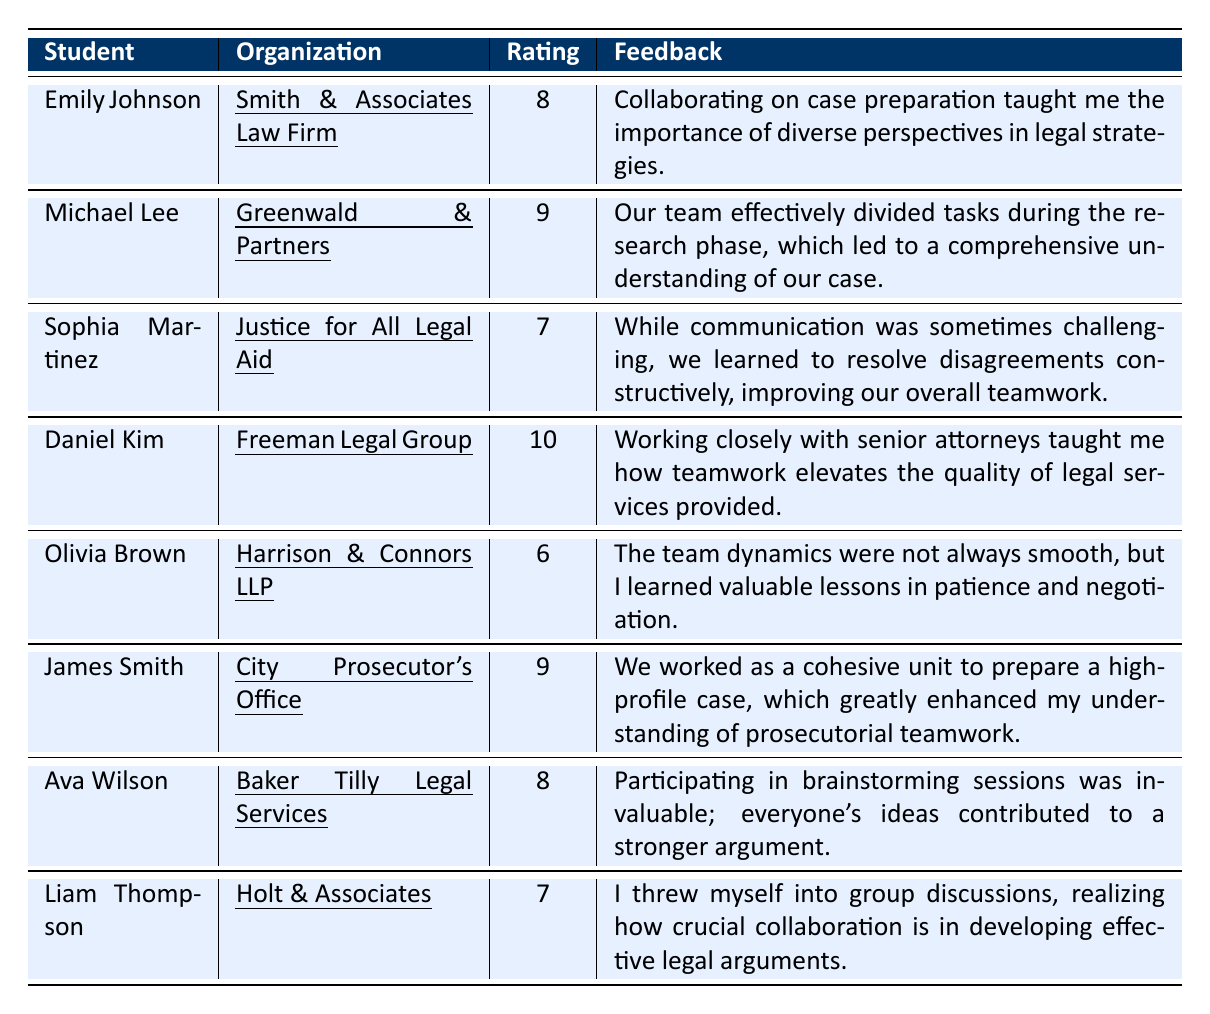What was the highest teamwork experience rating? The ratings range from 6 to 10. The highest value noted in the table is 10, given by Daniel Kim for his internship at Freeman Legal Group.
Answer: 10 Who provided feedback about effective task division? Michael Lee, during his internship at Greenwald & Partners, mentioned that the team effectively divided tasks during the research phase.
Answer: Michael Lee How many students rated their teamwork experience as 9? There are two students who rated their teamwork experience as 9: Michael Lee and James Smith.
Answer: 2 What is the average teamwork experience rating from all students? Adding the ratings gives: 8 + 9 + 7 + 10 + 6 + 9 + 8 + 7 = 64. There are 8 students, so the average is 64/8 = 8.
Answer: 8 Did any student mention learning about negotiation in their feedback? Yes, Olivia Brown specifically mentioned learning valuable lessons in patience and negotiation during her internship.
Answer: Yes Which organization had the student with the lowest teamwork experience rating? Olivia Brown from Harrison & Connors LLP rated her teamwork experience as 6, which is the lowest rating among all students.
Answer: Harrison & Connors LLP What feedback did Ava Wilson provide regarding brainstorming sessions? Ava Wilson stated that participating in brainstorming sessions was invaluable and everyone’s ideas contributed to a stronger argument.
Answer: Invaluable contributions to arguments Was there a student who found communication challenging during their teamwork experience? Yes, Sophia Martinez mentioned that communication was sometimes challenging but they learned to resolve disagreements constructively.
Answer: Yes What can be inferred about Daniel Kim's experience compared to others regarding teamwork? Daniel Kim rated his experience at a 10, the highest among all, and emphasized that working closely with senior attorneys elevated the quality of legal services provided, suggesting he had an exceptionally positive experience.
Answer: Exceptionally positive experience 